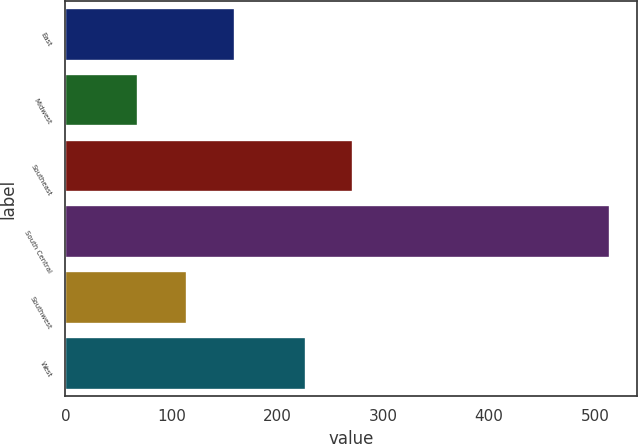Convert chart. <chart><loc_0><loc_0><loc_500><loc_500><bar_chart><fcel>East<fcel>Midwest<fcel>Southeast<fcel>South Central<fcel>Southwest<fcel>West<nl><fcel>159.64<fcel>68.7<fcel>271.84<fcel>514.1<fcel>115.1<fcel>227.3<nl></chart> 